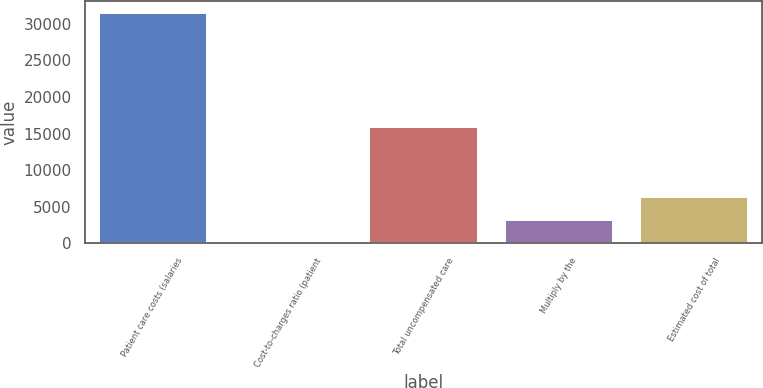Convert chart to OTSL. <chart><loc_0><loc_0><loc_500><loc_500><bar_chart><fcel>Patient care costs (salaries<fcel>Cost-to-charges ratio (patient<fcel>Total uncompensated care<fcel>Multiply by the<fcel>Estimated cost of total<nl><fcel>31478<fcel>15.5<fcel>15943<fcel>3161.75<fcel>6308<nl></chart> 